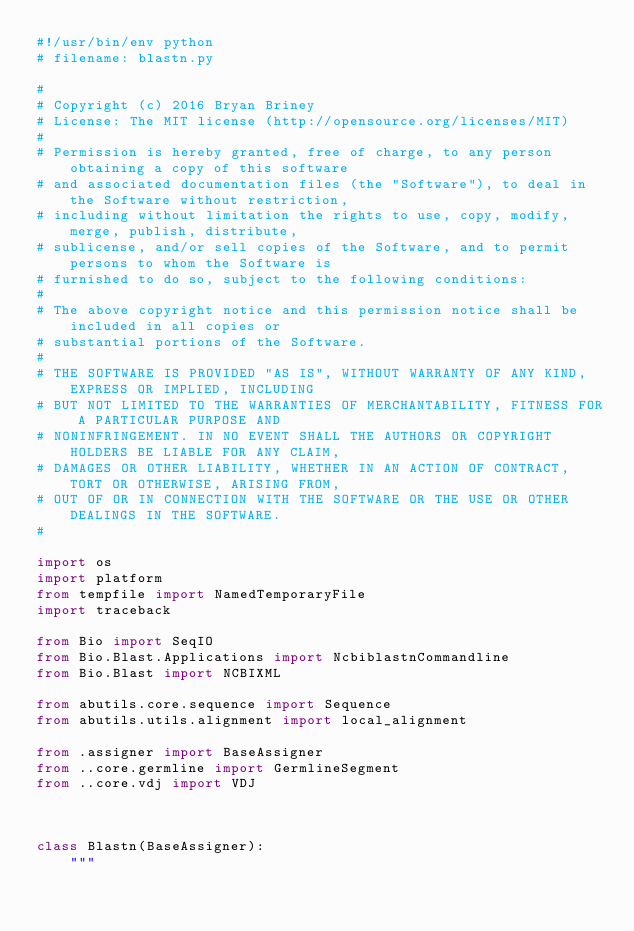Convert code to text. <code><loc_0><loc_0><loc_500><loc_500><_Python_>#!/usr/bin/env python
# filename: blastn.py

#
# Copyright (c) 2016 Bryan Briney
# License: The MIT license (http://opensource.org/licenses/MIT)
#
# Permission is hereby granted, free of charge, to any person obtaining a copy of this software
# and associated documentation files (the "Software"), to deal in the Software without restriction,
# including without limitation the rights to use, copy, modify, merge, publish, distribute,
# sublicense, and/or sell copies of the Software, and to permit persons to whom the Software is
# furnished to do so, subject to the following conditions:
#
# The above copyright notice and this permission notice shall be included in all copies or
# substantial portions of the Software.
#
# THE SOFTWARE IS PROVIDED "AS IS", WITHOUT WARRANTY OF ANY KIND, EXPRESS OR IMPLIED, INCLUDING
# BUT NOT LIMITED TO THE WARRANTIES OF MERCHANTABILITY, FITNESS FOR A PARTICULAR PURPOSE AND
# NONINFRINGEMENT. IN NO EVENT SHALL THE AUTHORS OR COPYRIGHT HOLDERS BE LIABLE FOR ANY CLAIM,
# DAMAGES OR OTHER LIABILITY, WHETHER IN AN ACTION OF CONTRACT, TORT OR OTHERWISE, ARISING FROM,
# OUT OF OR IN CONNECTION WITH THE SOFTWARE OR THE USE OR OTHER DEALINGS IN THE SOFTWARE.
#

import os
import platform
from tempfile import NamedTemporaryFile
import traceback

from Bio import SeqIO
from Bio.Blast.Applications import NcbiblastnCommandline
from Bio.Blast import NCBIXML

from abutils.core.sequence import Sequence
from abutils.utils.alignment import local_alignment

from .assigner import BaseAssigner
from ..core.germline import GermlineSegment
from ..core.vdj import VDJ



class Blastn(BaseAssigner):
    """</code> 